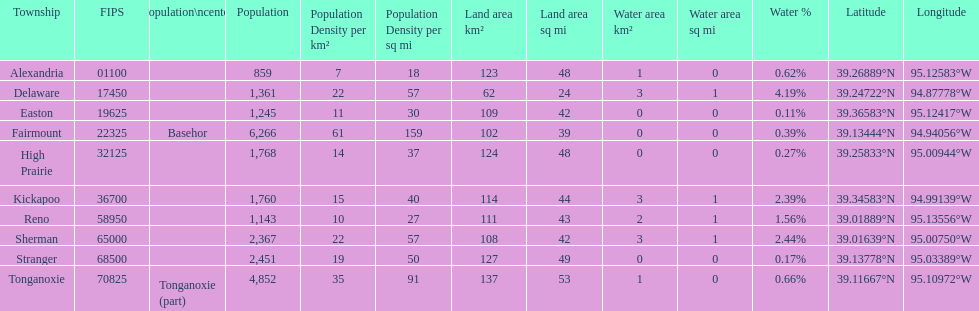Was delaware's land area above or below 45 square miles? Above. 